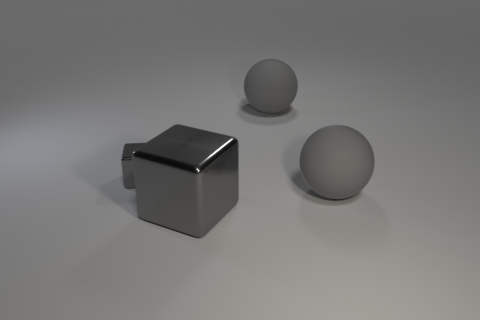Add 4 small cyan rubber spheres. How many objects exist? 8 Subtract all big gray rubber spheres. Subtract all big gray balls. How many objects are left? 0 Add 4 big gray matte objects. How many big gray matte objects are left? 6 Add 1 big matte objects. How many big matte objects exist? 3 Subtract 0 green blocks. How many objects are left? 4 